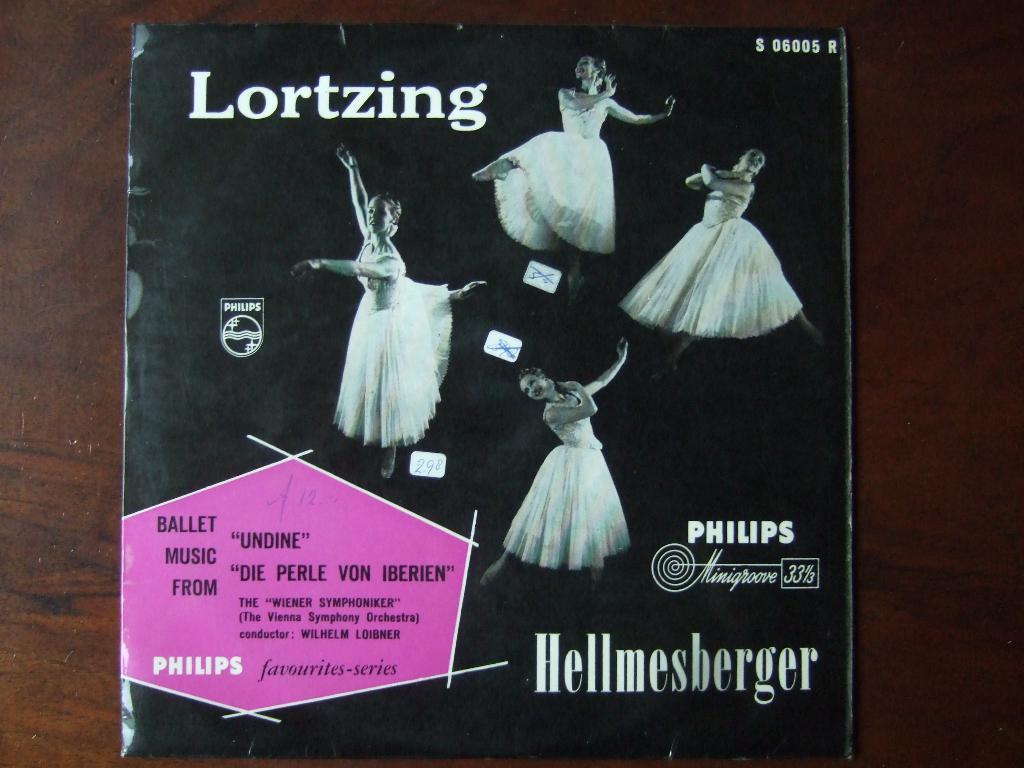What is the main subject of the image? The main subject of the image is a black color card. What is happening on the card? Four persons are dancing on the card. What are the dancers wearing? The dancers are wearing white color dress. What is the card placed on? The card is on a brown color surface. Can you see a cork, chain, or kettle in the image? No, there is no cork, chain, or kettle present in the image. 